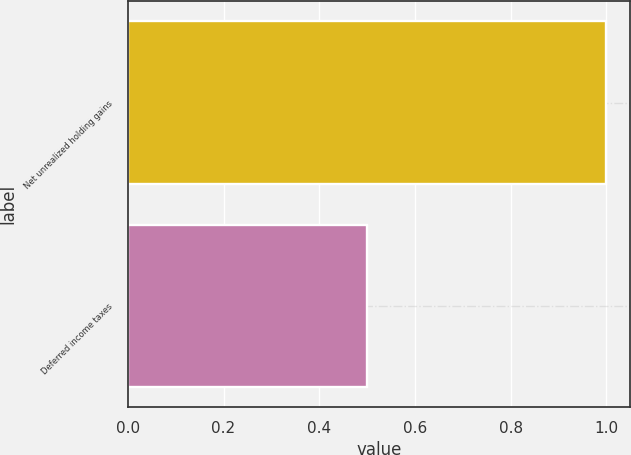Convert chart to OTSL. <chart><loc_0><loc_0><loc_500><loc_500><bar_chart><fcel>Net unrealized holding gains<fcel>Deferred income taxes<nl><fcel>1<fcel>0.5<nl></chart> 